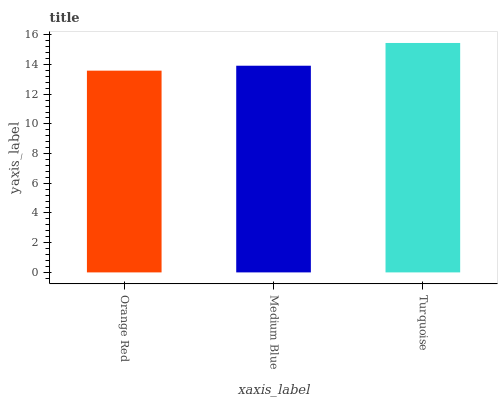Is Medium Blue the minimum?
Answer yes or no. No. Is Medium Blue the maximum?
Answer yes or no. No. Is Medium Blue greater than Orange Red?
Answer yes or no. Yes. Is Orange Red less than Medium Blue?
Answer yes or no. Yes. Is Orange Red greater than Medium Blue?
Answer yes or no. No. Is Medium Blue less than Orange Red?
Answer yes or no. No. Is Medium Blue the high median?
Answer yes or no. Yes. Is Medium Blue the low median?
Answer yes or no. Yes. Is Orange Red the high median?
Answer yes or no. No. Is Turquoise the low median?
Answer yes or no. No. 